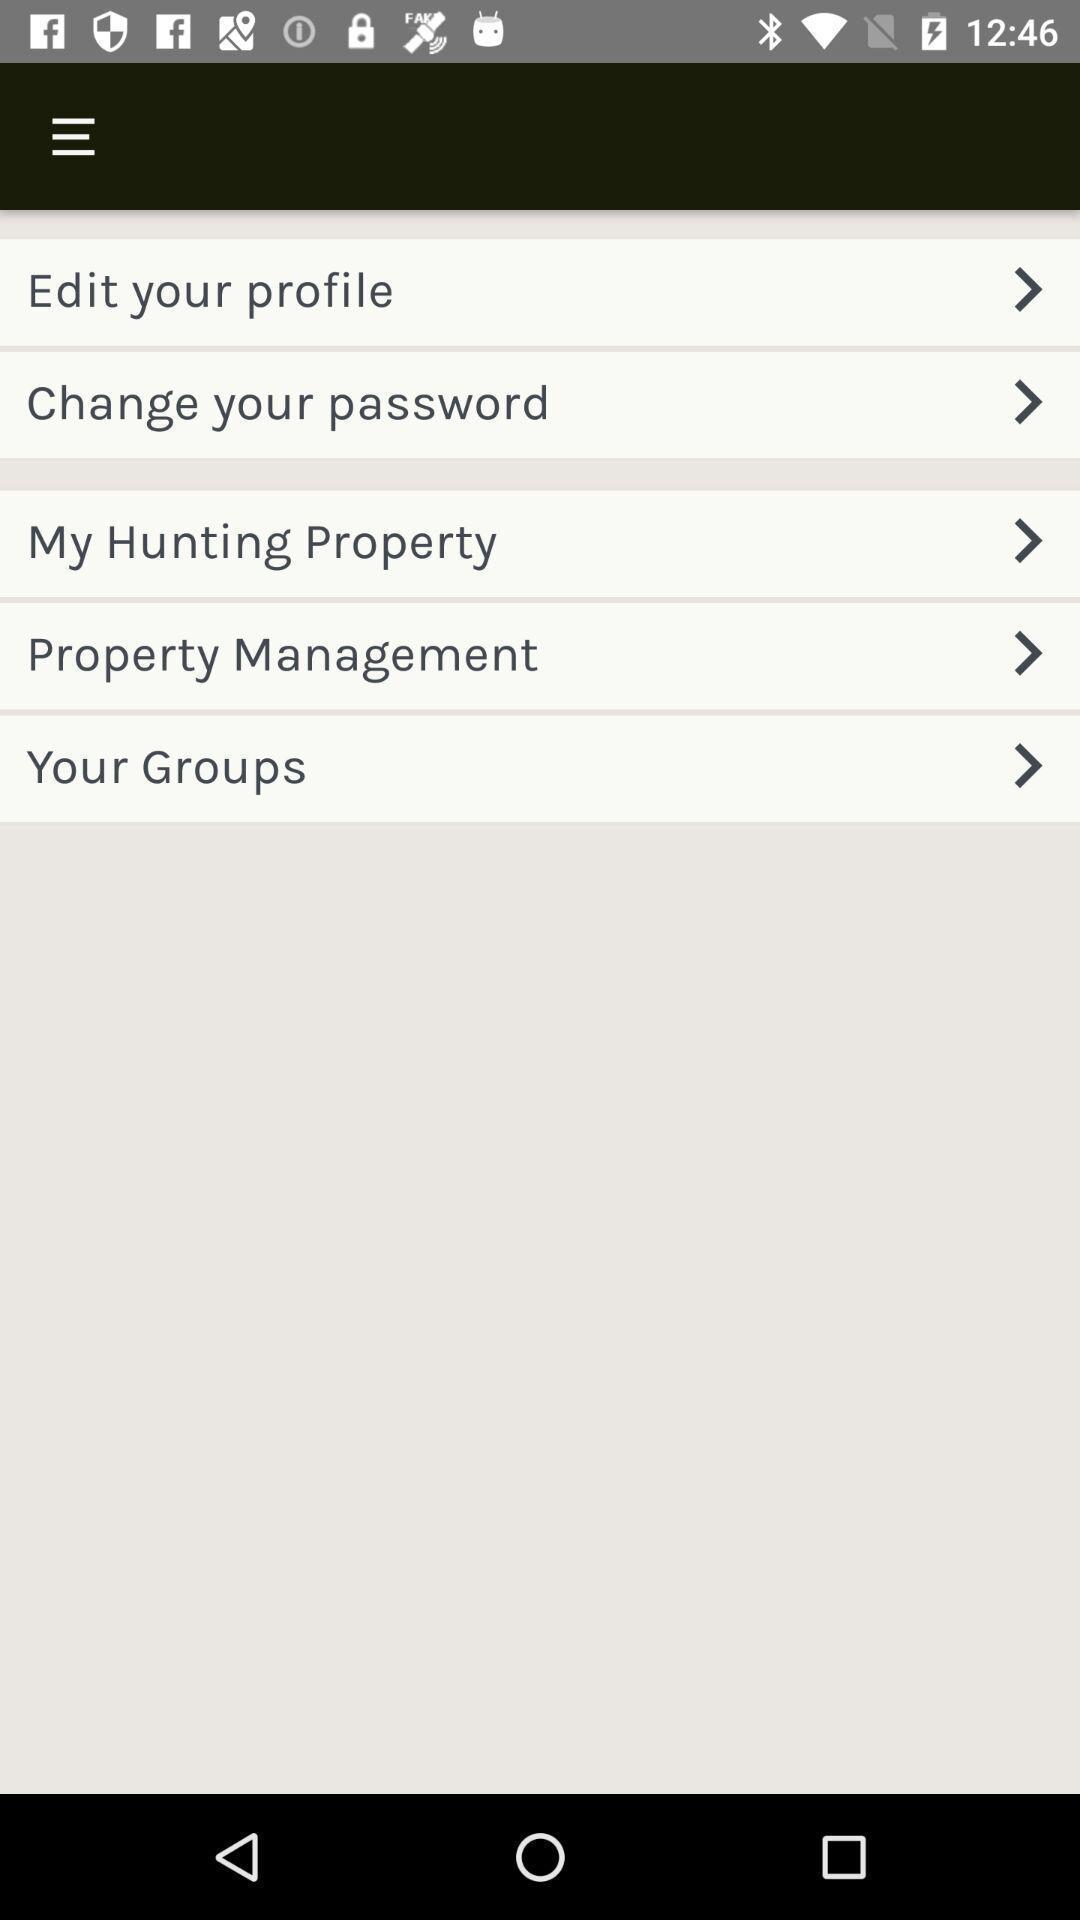Please provide a description for this image. Screen shows different options. 